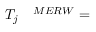Convert formula to latex. <formula><loc_0><loc_0><loc_500><loc_500>\begin{array} { r l } { T _ { j } } & ^ { M E R W } = } \end{array}</formula> 